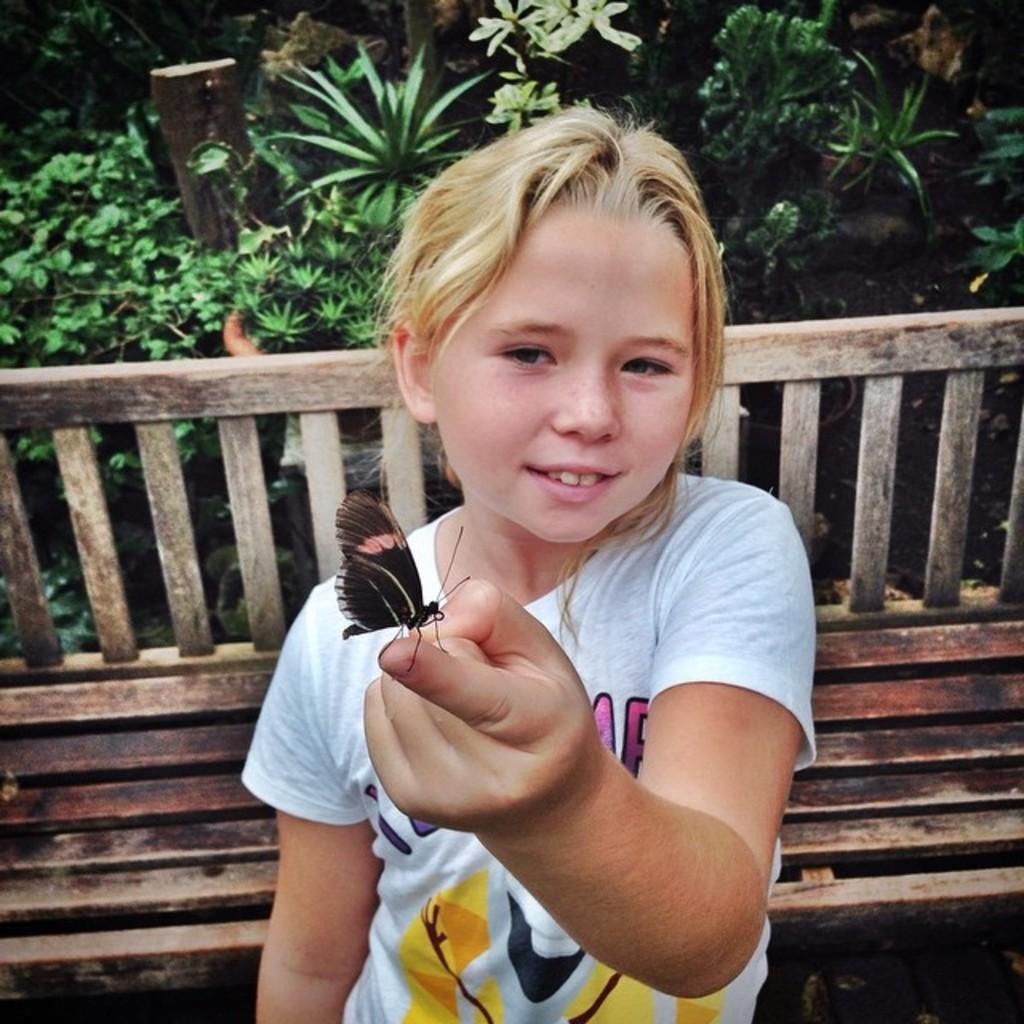Who is the main subject in the image? There is a girl in the image. What is the girl doing in the image? The girl is standing and holding a butterfly. What can be seen in the background of the image? There is a bench and plants in the background of the image. What type of goldfish can be seen swimming in the image? There are no goldfish present in the image; it features a girl holding a butterfly. How does the girl's temper affect the plants in the background? The girl's temper is not mentioned in the image, and there is no indication that it affects the plants. 